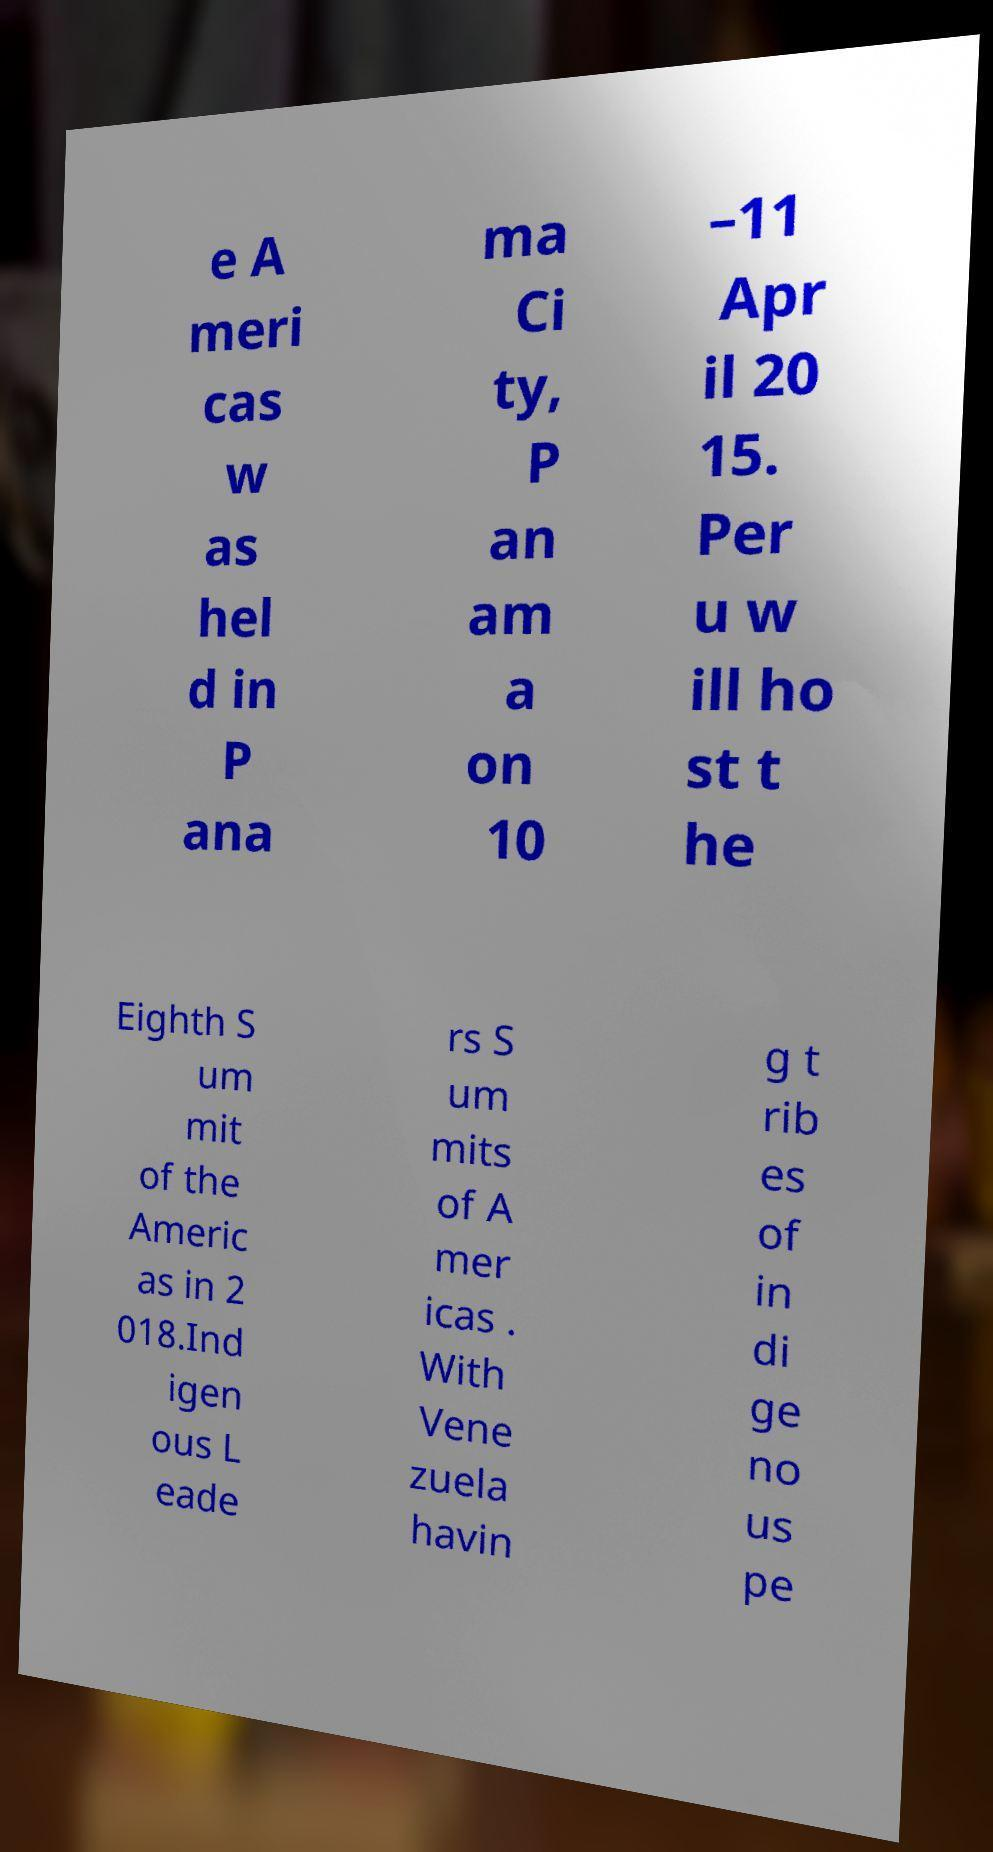For documentation purposes, I need the text within this image transcribed. Could you provide that? e A meri cas w as hel d in P ana ma Ci ty, P an am a on 10 –11 Apr il 20 15. Per u w ill ho st t he Eighth S um mit of the Americ as in 2 018.Ind igen ous L eade rs S um mits of A mer icas . With Vene zuela havin g t rib es of in di ge no us pe 